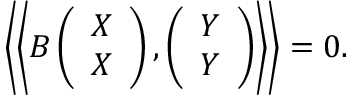Convert formula to latex. <formula><loc_0><loc_0><loc_500><loc_500>\left \langle \left \langle B \left ( \begin{array} { c } { X } \\ { X } \end{array} \right ) , \left ( \begin{array} { c } { Y } \\ { Y } \end{array} \right ) \right \rangle \right \rangle = 0 .</formula> 